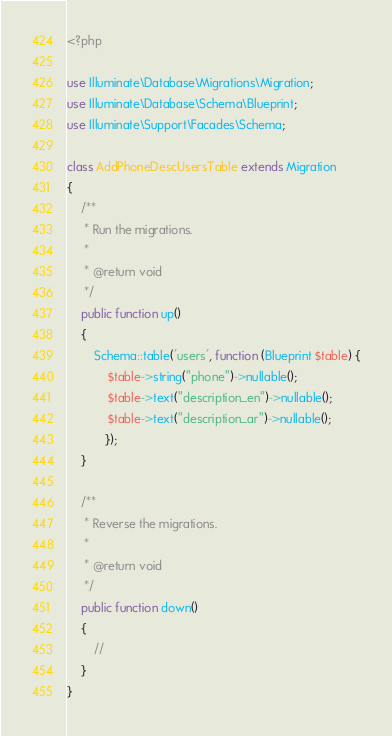Convert code to text. <code><loc_0><loc_0><loc_500><loc_500><_PHP_><?php

use Illuminate\Database\Migrations\Migration;
use Illuminate\Database\Schema\Blueprint;
use Illuminate\Support\Facades\Schema;

class AddPhoneDescUsersTable extends Migration
{
    /**
     * Run the migrations.
     *
     * @return void
     */
    public function up()
    {
        Schema::table('users', function (Blueprint $table) {
            $table->string("phone")->nullable();
            $table->text("description_en")->nullable();
            $table->text("description_ar")->nullable();
           });
    }

    /**
     * Reverse the migrations.
     *
     * @return void
     */
    public function down()
    {
        //
    }
}
</code> 